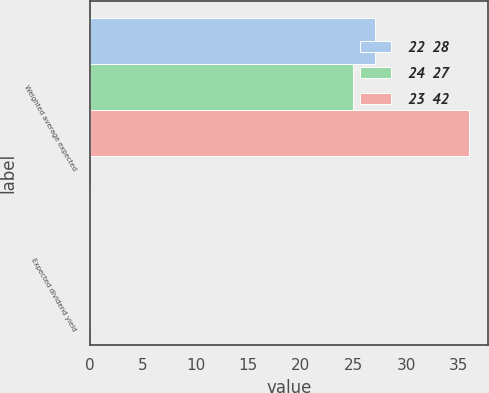Convert chart. <chart><loc_0><loc_0><loc_500><loc_500><stacked_bar_chart><ecel><fcel>Weighted average expected<fcel>Expected dividend yield<nl><fcel>22  28<fcel>27<fcel>0<nl><fcel>24  27<fcel>25<fcel>0<nl><fcel>23  42<fcel>36<fcel>0<nl></chart> 